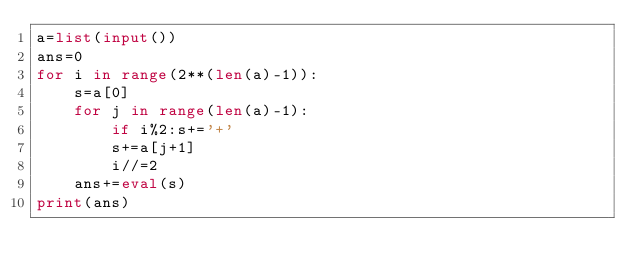<code> <loc_0><loc_0><loc_500><loc_500><_Python_>a=list(input())
ans=0
for i in range(2**(len(a)-1)):
    s=a[0]
    for j in range(len(a)-1):
        if i%2:s+='+'
        s+=a[j+1]
        i//=2
    ans+=eval(s)
print(ans)</code> 